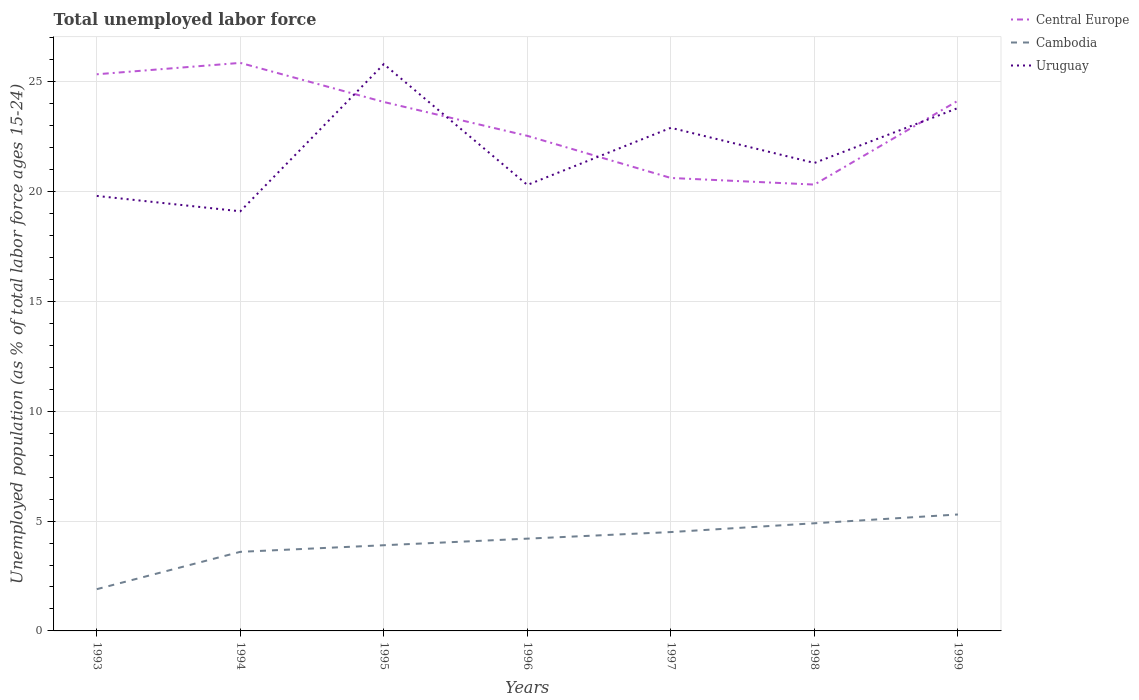Across all years, what is the maximum percentage of unemployed population in in Uruguay?
Offer a very short reply. 19.1. What is the total percentage of unemployed population in in Cambodia in the graph?
Give a very brief answer. -0.3. What is the difference between the highest and the second highest percentage of unemployed population in in Cambodia?
Ensure brevity in your answer.  3.4. What is the difference between the highest and the lowest percentage of unemployed population in in Uruguay?
Ensure brevity in your answer.  3. Is the percentage of unemployed population in in Central Europe strictly greater than the percentage of unemployed population in in Uruguay over the years?
Provide a short and direct response. No. How many lines are there?
Your answer should be very brief. 3. Does the graph contain any zero values?
Keep it short and to the point. No. How many legend labels are there?
Keep it short and to the point. 3. What is the title of the graph?
Provide a short and direct response. Total unemployed labor force. What is the label or title of the Y-axis?
Provide a short and direct response. Unemployed population (as % of total labor force ages 15-24). What is the Unemployed population (as % of total labor force ages 15-24) of Central Europe in 1993?
Offer a terse response. 25.34. What is the Unemployed population (as % of total labor force ages 15-24) in Cambodia in 1993?
Your response must be concise. 1.9. What is the Unemployed population (as % of total labor force ages 15-24) of Uruguay in 1993?
Your answer should be very brief. 19.8. What is the Unemployed population (as % of total labor force ages 15-24) in Central Europe in 1994?
Provide a short and direct response. 25.85. What is the Unemployed population (as % of total labor force ages 15-24) in Cambodia in 1994?
Keep it short and to the point. 3.6. What is the Unemployed population (as % of total labor force ages 15-24) of Uruguay in 1994?
Your answer should be very brief. 19.1. What is the Unemployed population (as % of total labor force ages 15-24) in Central Europe in 1995?
Your response must be concise. 24.07. What is the Unemployed population (as % of total labor force ages 15-24) of Cambodia in 1995?
Keep it short and to the point. 3.9. What is the Unemployed population (as % of total labor force ages 15-24) of Uruguay in 1995?
Your answer should be very brief. 25.8. What is the Unemployed population (as % of total labor force ages 15-24) in Central Europe in 1996?
Provide a succinct answer. 22.53. What is the Unemployed population (as % of total labor force ages 15-24) of Cambodia in 1996?
Provide a short and direct response. 4.2. What is the Unemployed population (as % of total labor force ages 15-24) of Uruguay in 1996?
Provide a short and direct response. 20.3. What is the Unemployed population (as % of total labor force ages 15-24) of Central Europe in 1997?
Provide a succinct answer. 20.62. What is the Unemployed population (as % of total labor force ages 15-24) of Uruguay in 1997?
Give a very brief answer. 22.9. What is the Unemployed population (as % of total labor force ages 15-24) of Central Europe in 1998?
Provide a short and direct response. 20.32. What is the Unemployed population (as % of total labor force ages 15-24) in Cambodia in 1998?
Your answer should be compact. 4.9. What is the Unemployed population (as % of total labor force ages 15-24) of Uruguay in 1998?
Offer a terse response. 21.3. What is the Unemployed population (as % of total labor force ages 15-24) in Central Europe in 1999?
Your response must be concise. 24.13. What is the Unemployed population (as % of total labor force ages 15-24) of Cambodia in 1999?
Ensure brevity in your answer.  5.3. What is the Unemployed population (as % of total labor force ages 15-24) of Uruguay in 1999?
Give a very brief answer. 23.8. Across all years, what is the maximum Unemployed population (as % of total labor force ages 15-24) in Central Europe?
Give a very brief answer. 25.85. Across all years, what is the maximum Unemployed population (as % of total labor force ages 15-24) in Cambodia?
Your answer should be very brief. 5.3. Across all years, what is the maximum Unemployed population (as % of total labor force ages 15-24) in Uruguay?
Your answer should be compact. 25.8. Across all years, what is the minimum Unemployed population (as % of total labor force ages 15-24) of Central Europe?
Your answer should be compact. 20.32. Across all years, what is the minimum Unemployed population (as % of total labor force ages 15-24) of Cambodia?
Your answer should be compact. 1.9. Across all years, what is the minimum Unemployed population (as % of total labor force ages 15-24) of Uruguay?
Offer a very short reply. 19.1. What is the total Unemployed population (as % of total labor force ages 15-24) of Central Europe in the graph?
Your answer should be very brief. 162.86. What is the total Unemployed population (as % of total labor force ages 15-24) in Cambodia in the graph?
Your response must be concise. 28.3. What is the total Unemployed population (as % of total labor force ages 15-24) of Uruguay in the graph?
Provide a short and direct response. 153. What is the difference between the Unemployed population (as % of total labor force ages 15-24) of Central Europe in 1993 and that in 1994?
Your answer should be very brief. -0.52. What is the difference between the Unemployed population (as % of total labor force ages 15-24) of Cambodia in 1993 and that in 1994?
Make the answer very short. -1.7. What is the difference between the Unemployed population (as % of total labor force ages 15-24) of Uruguay in 1993 and that in 1994?
Ensure brevity in your answer.  0.7. What is the difference between the Unemployed population (as % of total labor force ages 15-24) in Central Europe in 1993 and that in 1995?
Keep it short and to the point. 1.26. What is the difference between the Unemployed population (as % of total labor force ages 15-24) in Uruguay in 1993 and that in 1995?
Ensure brevity in your answer.  -6. What is the difference between the Unemployed population (as % of total labor force ages 15-24) of Central Europe in 1993 and that in 1996?
Your response must be concise. 2.8. What is the difference between the Unemployed population (as % of total labor force ages 15-24) of Uruguay in 1993 and that in 1996?
Make the answer very short. -0.5. What is the difference between the Unemployed population (as % of total labor force ages 15-24) in Central Europe in 1993 and that in 1997?
Provide a short and direct response. 4.72. What is the difference between the Unemployed population (as % of total labor force ages 15-24) in Cambodia in 1993 and that in 1997?
Your answer should be compact. -2.6. What is the difference between the Unemployed population (as % of total labor force ages 15-24) of Central Europe in 1993 and that in 1998?
Give a very brief answer. 5.02. What is the difference between the Unemployed population (as % of total labor force ages 15-24) in Cambodia in 1993 and that in 1998?
Give a very brief answer. -3. What is the difference between the Unemployed population (as % of total labor force ages 15-24) in Central Europe in 1993 and that in 1999?
Offer a very short reply. 1.2. What is the difference between the Unemployed population (as % of total labor force ages 15-24) of Cambodia in 1993 and that in 1999?
Give a very brief answer. -3.4. What is the difference between the Unemployed population (as % of total labor force ages 15-24) of Central Europe in 1994 and that in 1995?
Your response must be concise. 1.78. What is the difference between the Unemployed population (as % of total labor force ages 15-24) in Cambodia in 1994 and that in 1995?
Your answer should be compact. -0.3. What is the difference between the Unemployed population (as % of total labor force ages 15-24) in Central Europe in 1994 and that in 1996?
Provide a succinct answer. 3.32. What is the difference between the Unemployed population (as % of total labor force ages 15-24) of Cambodia in 1994 and that in 1996?
Your answer should be very brief. -0.6. What is the difference between the Unemployed population (as % of total labor force ages 15-24) in Central Europe in 1994 and that in 1997?
Offer a terse response. 5.24. What is the difference between the Unemployed population (as % of total labor force ages 15-24) of Cambodia in 1994 and that in 1997?
Provide a succinct answer. -0.9. What is the difference between the Unemployed population (as % of total labor force ages 15-24) in Central Europe in 1994 and that in 1998?
Give a very brief answer. 5.54. What is the difference between the Unemployed population (as % of total labor force ages 15-24) of Cambodia in 1994 and that in 1998?
Keep it short and to the point. -1.3. What is the difference between the Unemployed population (as % of total labor force ages 15-24) in Uruguay in 1994 and that in 1998?
Give a very brief answer. -2.2. What is the difference between the Unemployed population (as % of total labor force ages 15-24) in Central Europe in 1994 and that in 1999?
Provide a short and direct response. 1.72. What is the difference between the Unemployed population (as % of total labor force ages 15-24) in Uruguay in 1994 and that in 1999?
Provide a succinct answer. -4.7. What is the difference between the Unemployed population (as % of total labor force ages 15-24) in Central Europe in 1995 and that in 1996?
Ensure brevity in your answer.  1.54. What is the difference between the Unemployed population (as % of total labor force ages 15-24) in Cambodia in 1995 and that in 1996?
Provide a succinct answer. -0.3. What is the difference between the Unemployed population (as % of total labor force ages 15-24) of Central Europe in 1995 and that in 1997?
Provide a short and direct response. 3.46. What is the difference between the Unemployed population (as % of total labor force ages 15-24) in Cambodia in 1995 and that in 1997?
Provide a succinct answer. -0.6. What is the difference between the Unemployed population (as % of total labor force ages 15-24) of Uruguay in 1995 and that in 1997?
Your answer should be very brief. 2.9. What is the difference between the Unemployed population (as % of total labor force ages 15-24) of Central Europe in 1995 and that in 1998?
Make the answer very short. 3.76. What is the difference between the Unemployed population (as % of total labor force ages 15-24) of Uruguay in 1995 and that in 1998?
Ensure brevity in your answer.  4.5. What is the difference between the Unemployed population (as % of total labor force ages 15-24) of Central Europe in 1995 and that in 1999?
Your response must be concise. -0.06. What is the difference between the Unemployed population (as % of total labor force ages 15-24) in Cambodia in 1995 and that in 1999?
Keep it short and to the point. -1.4. What is the difference between the Unemployed population (as % of total labor force ages 15-24) of Uruguay in 1995 and that in 1999?
Your answer should be very brief. 2. What is the difference between the Unemployed population (as % of total labor force ages 15-24) in Central Europe in 1996 and that in 1997?
Offer a very short reply. 1.92. What is the difference between the Unemployed population (as % of total labor force ages 15-24) in Central Europe in 1996 and that in 1998?
Make the answer very short. 2.22. What is the difference between the Unemployed population (as % of total labor force ages 15-24) of Uruguay in 1996 and that in 1998?
Ensure brevity in your answer.  -1. What is the difference between the Unemployed population (as % of total labor force ages 15-24) in Central Europe in 1996 and that in 1999?
Ensure brevity in your answer.  -1.6. What is the difference between the Unemployed population (as % of total labor force ages 15-24) of Central Europe in 1997 and that in 1998?
Ensure brevity in your answer.  0.3. What is the difference between the Unemployed population (as % of total labor force ages 15-24) of Uruguay in 1997 and that in 1998?
Your response must be concise. 1.6. What is the difference between the Unemployed population (as % of total labor force ages 15-24) in Central Europe in 1997 and that in 1999?
Offer a very short reply. -3.52. What is the difference between the Unemployed population (as % of total labor force ages 15-24) of Cambodia in 1997 and that in 1999?
Your answer should be compact. -0.8. What is the difference between the Unemployed population (as % of total labor force ages 15-24) of Central Europe in 1998 and that in 1999?
Your answer should be compact. -3.82. What is the difference between the Unemployed population (as % of total labor force ages 15-24) of Cambodia in 1998 and that in 1999?
Offer a terse response. -0.4. What is the difference between the Unemployed population (as % of total labor force ages 15-24) of Uruguay in 1998 and that in 1999?
Ensure brevity in your answer.  -2.5. What is the difference between the Unemployed population (as % of total labor force ages 15-24) in Central Europe in 1993 and the Unemployed population (as % of total labor force ages 15-24) in Cambodia in 1994?
Your response must be concise. 21.74. What is the difference between the Unemployed population (as % of total labor force ages 15-24) in Central Europe in 1993 and the Unemployed population (as % of total labor force ages 15-24) in Uruguay in 1994?
Your answer should be compact. 6.24. What is the difference between the Unemployed population (as % of total labor force ages 15-24) in Cambodia in 1993 and the Unemployed population (as % of total labor force ages 15-24) in Uruguay in 1994?
Give a very brief answer. -17.2. What is the difference between the Unemployed population (as % of total labor force ages 15-24) in Central Europe in 1993 and the Unemployed population (as % of total labor force ages 15-24) in Cambodia in 1995?
Your answer should be very brief. 21.44. What is the difference between the Unemployed population (as % of total labor force ages 15-24) in Central Europe in 1993 and the Unemployed population (as % of total labor force ages 15-24) in Uruguay in 1995?
Give a very brief answer. -0.46. What is the difference between the Unemployed population (as % of total labor force ages 15-24) of Cambodia in 1993 and the Unemployed population (as % of total labor force ages 15-24) of Uruguay in 1995?
Your response must be concise. -23.9. What is the difference between the Unemployed population (as % of total labor force ages 15-24) of Central Europe in 1993 and the Unemployed population (as % of total labor force ages 15-24) of Cambodia in 1996?
Make the answer very short. 21.14. What is the difference between the Unemployed population (as % of total labor force ages 15-24) in Central Europe in 1993 and the Unemployed population (as % of total labor force ages 15-24) in Uruguay in 1996?
Your response must be concise. 5.04. What is the difference between the Unemployed population (as % of total labor force ages 15-24) in Cambodia in 1993 and the Unemployed population (as % of total labor force ages 15-24) in Uruguay in 1996?
Offer a terse response. -18.4. What is the difference between the Unemployed population (as % of total labor force ages 15-24) of Central Europe in 1993 and the Unemployed population (as % of total labor force ages 15-24) of Cambodia in 1997?
Give a very brief answer. 20.84. What is the difference between the Unemployed population (as % of total labor force ages 15-24) in Central Europe in 1993 and the Unemployed population (as % of total labor force ages 15-24) in Uruguay in 1997?
Offer a terse response. 2.44. What is the difference between the Unemployed population (as % of total labor force ages 15-24) of Central Europe in 1993 and the Unemployed population (as % of total labor force ages 15-24) of Cambodia in 1998?
Your answer should be compact. 20.44. What is the difference between the Unemployed population (as % of total labor force ages 15-24) in Central Europe in 1993 and the Unemployed population (as % of total labor force ages 15-24) in Uruguay in 1998?
Your answer should be very brief. 4.04. What is the difference between the Unemployed population (as % of total labor force ages 15-24) of Cambodia in 1993 and the Unemployed population (as % of total labor force ages 15-24) of Uruguay in 1998?
Your answer should be compact. -19.4. What is the difference between the Unemployed population (as % of total labor force ages 15-24) in Central Europe in 1993 and the Unemployed population (as % of total labor force ages 15-24) in Cambodia in 1999?
Your answer should be compact. 20.04. What is the difference between the Unemployed population (as % of total labor force ages 15-24) in Central Europe in 1993 and the Unemployed population (as % of total labor force ages 15-24) in Uruguay in 1999?
Your answer should be compact. 1.54. What is the difference between the Unemployed population (as % of total labor force ages 15-24) of Cambodia in 1993 and the Unemployed population (as % of total labor force ages 15-24) of Uruguay in 1999?
Your answer should be very brief. -21.9. What is the difference between the Unemployed population (as % of total labor force ages 15-24) of Central Europe in 1994 and the Unemployed population (as % of total labor force ages 15-24) of Cambodia in 1995?
Your answer should be very brief. 21.95. What is the difference between the Unemployed population (as % of total labor force ages 15-24) in Central Europe in 1994 and the Unemployed population (as % of total labor force ages 15-24) in Uruguay in 1995?
Your answer should be very brief. 0.05. What is the difference between the Unemployed population (as % of total labor force ages 15-24) in Cambodia in 1994 and the Unemployed population (as % of total labor force ages 15-24) in Uruguay in 1995?
Give a very brief answer. -22.2. What is the difference between the Unemployed population (as % of total labor force ages 15-24) in Central Europe in 1994 and the Unemployed population (as % of total labor force ages 15-24) in Cambodia in 1996?
Offer a terse response. 21.65. What is the difference between the Unemployed population (as % of total labor force ages 15-24) of Central Europe in 1994 and the Unemployed population (as % of total labor force ages 15-24) of Uruguay in 1996?
Keep it short and to the point. 5.55. What is the difference between the Unemployed population (as % of total labor force ages 15-24) in Cambodia in 1994 and the Unemployed population (as % of total labor force ages 15-24) in Uruguay in 1996?
Provide a short and direct response. -16.7. What is the difference between the Unemployed population (as % of total labor force ages 15-24) in Central Europe in 1994 and the Unemployed population (as % of total labor force ages 15-24) in Cambodia in 1997?
Your response must be concise. 21.35. What is the difference between the Unemployed population (as % of total labor force ages 15-24) of Central Europe in 1994 and the Unemployed population (as % of total labor force ages 15-24) of Uruguay in 1997?
Offer a very short reply. 2.95. What is the difference between the Unemployed population (as % of total labor force ages 15-24) in Cambodia in 1994 and the Unemployed population (as % of total labor force ages 15-24) in Uruguay in 1997?
Make the answer very short. -19.3. What is the difference between the Unemployed population (as % of total labor force ages 15-24) in Central Europe in 1994 and the Unemployed population (as % of total labor force ages 15-24) in Cambodia in 1998?
Make the answer very short. 20.95. What is the difference between the Unemployed population (as % of total labor force ages 15-24) in Central Europe in 1994 and the Unemployed population (as % of total labor force ages 15-24) in Uruguay in 1998?
Your answer should be compact. 4.55. What is the difference between the Unemployed population (as % of total labor force ages 15-24) of Cambodia in 1994 and the Unemployed population (as % of total labor force ages 15-24) of Uruguay in 1998?
Make the answer very short. -17.7. What is the difference between the Unemployed population (as % of total labor force ages 15-24) in Central Europe in 1994 and the Unemployed population (as % of total labor force ages 15-24) in Cambodia in 1999?
Keep it short and to the point. 20.55. What is the difference between the Unemployed population (as % of total labor force ages 15-24) in Central Europe in 1994 and the Unemployed population (as % of total labor force ages 15-24) in Uruguay in 1999?
Your response must be concise. 2.05. What is the difference between the Unemployed population (as % of total labor force ages 15-24) in Cambodia in 1994 and the Unemployed population (as % of total labor force ages 15-24) in Uruguay in 1999?
Give a very brief answer. -20.2. What is the difference between the Unemployed population (as % of total labor force ages 15-24) of Central Europe in 1995 and the Unemployed population (as % of total labor force ages 15-24) of Cambodia in 1996?
Offer a very short reply. 19.87. What is the difference between the Unemployed population (as % of total labor force ages 15-24) of Central Europe in 1995 and the Unemployed population (as % of total labor force ages 15-24) of Uruguay in 1996?
Give a very brief answer. 3.77. What is the difference between the Unemployed population (as % of total labor force ages 15-24) of Cambodia in 1995 and the Unemployed population (as % of total labor force ages 15-24) of Uruguay in 1996?
Provide a succinct answer. -16.4. What is the difference between the Unemployed population (as % of total labor force ages 15-24) of Central Europe in 1995 and the Unemployed population (as % of total labor force ages 15-24) of Cambodia in 1997?
Offer a terse response. 19.57. What is the difference between the Unemployed population (as % of total labor force ages 15-24) in Central Europe in 1995 and the Unemployed population (as % of total labor force ages 15-24) in Uruguay in 1997?
Ensure brevity in your answer.  1.17. What is the difference between the Unemployed population (as % of total labor force ages 15-24) in Central Europe in 1995 and the Unemployed population (as % of total labor force ages 15-24) in Cambodia in 1998?
Give a very brief answer. 19.17. What is the difference between the Unemployed population (as % of total labor force ages 15-24) in Central Europe in 1995 and the Unemployed population (as % of total labor force ages 15-24) in Uruguay in 1998?
Offer a very short reply. 2.77. What is the difference between the Unemployed population (as % of total labor force ages 15-24) in Cambodia in 1995 and the Unemployed population (as % of total labor force ages 15-24) in Uruguay in 1998?
Your answer should be compact. -17.4. What is the difference between the Unemployed population (as % of total labor force ages 15-24) in Central Europe in 1995 and the Unemployed population (as % of total labor force ages 15-24) in Cambodia in 1999?
Provide a short and direct response. 18.77. What is the difference between the Unemployed population (as % of total labor force ages 15-24) in Central Europe in 1995 and the Unemployed population (as % of total labor force ages 15-24) in Uruguay in 1999?
Offer a terse response. 0.27. What is the difference between the Unemployed population (as % of total labor force ages 15-24) of Cambodia in 1995 and the Unemployed population (as % of total labor force ages 15-24) of Uruguay in 1999?
Ensure brevity in your answer.  -19.9. What is the difference between the Unemployed population (as % of total labor force ages 15-24) of Central Europe in 1996 and the Unemployed population (as % of total labor force ages 15-24) of Cambodia in 1997?
Offer a terse response. 18.03. What is the difference between the Unemployed population (as % of total labor force ages 15-24) in Central Europe in 1996 and the Unemployed population (as % of total labor force ages 15-24) in Uruguay in 1997?
Keep it short and to the point. -0.37. What is the difference between the Unemployed population (as % of total labor force ages 15-24) of Cambodia in 1996 and the Unemployed population (as % of total labor force ages 15-24) of Uruguay in 1997?
Offer a very short reply. -18.7. What is the difference between the Unemployed population (as % of total labor force ages 15-24) in Central Europe in 1996 and the Unemployed population (as % of total labor force ages 15-24) in Cambodia in 1998?
Make the answer very short. 17.63. What is the difference between the Unemployed population (as % of total labor force ages 15-24) of Central Europe in 1996 and the Unemployed population (as % of total labor force ages 15-24) of Uruguay in 1998?
Keep it short and to the point. 1.23. What is the difference between the Unemployed population (as % of total labor force ages 15-24) in Cambodia in 1996 and the Unemployed population (as % of total labor force ages 15-24) in Uruguay in 1998?
Your answer should be very brief. -17.1. What is the difference between the Unemployed population (as % of total labor force ages 15-24) in Central Europe in 1996 and the Unemployed population (as % of total labor force ages 15-24) in Cambodia in 1999?
Your response must be concise. 17.23. What is the difference between the Unemployed population (as % of total labor force ages 15-24) of Central Europe in 1996 and the Unemployed population (as % of total labor force ages 15-24) of Uruguay in 1999?
Keep it short and to the point. -1.27. What is the difference between the Unemployed population (as % of total labor force ages 15-24) of Cambodia in 1996 and the Unemployed population (as % of total labor force ages 15-24) of Uruguay in 1999?
Your answer should be very brief. -19.6. What is the difference between the Unemployed population (as % of total labor force ages 15-24) in Central Europe in 1997 and the Unemployed population (as % of total labor force ages 15-24) in Cambodia in 1998?
Offer a terse response. 15.72. What is the difference between the Unemployed population (as % of total labor force ages 15-24) of Central Europe in 1997 and the Unemployed population (as % of total labor force ages 15-24) of Uruguay in 1998?
Offer a very short reply. -0.68. What is the difference between the Unemployed population (as % of total labor force ages 15-24) of Cambodia in 1997 and the Unemployed population (as % of total labor force ages 15-24) of Uruguay in 1998?
Provide a short and direct response. -16.8. What is the difference between the Unemployed population (as % of total labor force ages 15-24) of Central Europe in 1997 and the Unemployed population (as % of total labor force ages 15-24) of Cambodia in 1999?
Offer a very short reply. 15.32. What is the difference between the Unemployed population (as % of total labor force ages 15-24) in Central Europe in 1997 and the Unemployed population (as % of total labor force ages 15-24) in Uruguay in 1999?
Give a very brief answer. -3.18. What is the difference between the Unemployed population (as % of total labor force ages 15-24) of Cambodia in 1997 and the Unemployed population (as % of total labor force ages 15-24) of Uruguay in 1999?
Your response must be concise. -19.3. What is the difference between the Unemployed population (as % of total labor force ages 15-24) in Central Europe in 1998 and the Unemployed population (as % of total labor force ages 15-24) in Cambodia in 1999?
Offer a very short reply. 15.02. What is the difference between the Unemployed population (as % of total labor force ages 15-24) in Central Europe in 1998 and the Unemployed population (as % of total labor force ages 15-24) in Uruguay in 1999?
Keep it short and to the point. -3.48. What is the difference between the Unemployed population (as % of total labor force ages 15-24) of Cambodia in 1998 and the Unemployed population (as % of total labor force ages 15-24) of Uruguay in 1999?
Ensure brevity in your answer.  -18.9. What is the average Unemployed population (as % of total labor force ages 15-24) of Central Europe per year?
Give a very brief answer. 23.27. What is the average Unemployed population (as % of total labor force ages 15-24) of Cambodia per year?
Give a very brief answer. 4.04. What is the average Unemployed population (as % of total labor force ages 15-24) in Uruguay per year?
Make the answer very short. 21.86. In the year 1993, what is the difference between the Unemployed population (as % of total labor force ages 15-24) of Central Europe and Unemployed population (as % of total labor force ages 15-24) of Cambodia?
Provide a short and direct response. 23.44. In the year 1993, what is the difference between the Unemployed population (as % of total labor force ages 15-24) in Central Europe and Unemployed population (as % of total labor force ages 15-24) in Uruguay?
Give a very brief answer. 5.54. In the year 1993, what is the difference between the Unemployed population (as % of total labor force ages 15-24) in Cambodia and Unemployed population (as % of total labor force ages 15-24) in Uruguay?
Keep it short and to the point. -17.9. In the year 1994, what is the difference between the Unemployed population (as % of total labor force ages 15-24) of Central Europe and Unemployed population (as % of total labor force ages 15-24) of Cambodia?
Your answer should be very brief. 22.25. In the year 1994, what is the difference between the Unemployed population (as % of total labor force ages 15-24) in Central Europe and Unemployed population (as % of total labor force ages 15-24) in Uruguay?
Provide a succinct answer. 6.75. In the year 1994, what is the difference between the Unemployed population (as % of total labor force ages 15-24) in Cambodia and Unemployed population (as % of total labor force ages 15-24) in Uruguay?
Ensure brevity in your answer.  -15.5. In the year 1995, what is the difference between the Unemployed population (as % of total labor force ages 15-24) in Central Europe and Unemployed population (as % of total labor force ages 15-24) in Cambodia?
Make the answer very short. 20.17. In the year 1995, what is the difference between the Unemployed population (as % of total labor force ages 15-24) of Central Europe and Unemployed population (as % of total labor force ages 15-24) of Uruguay?
Keep it short and to the point. -1.73. In the year 1995, what is the difference between the Unemployed population (as % of total labor force ages 15-24) of Cambodia and Unemployed population (as % of total labor force ages 15-24) of Uruguay?
Your response must be concise. -21.9. In the year 1996, what is the difference between the Unemployed population (as % of total labor force ages 15-24) in Central Europe and Unemployed population (as % of total labor force ages 15-24) in Cambodia?
Your answer should be very brief. 18.33. In the year 1996, what is the difference between the Unemployed population (as % of total labor force ages 15-24) of Central Europe and Unemployed population (as % of total labor force ages 15-24) of Uruguay?
Your answer should be compact. 2.23. In the year 1996, what is the difference between the Unemployed population (as % of total labor force ages 15-24) in Cambodia and Unemployed population (as % of total labor force ages 15-24) in Uruguay?
Offer a terse response. -16.1. In the year 1997, what is the difference between the Unemployed population (as % of total labor force ages 15-24) of Central Europe and Unemployed population (as % of total labor force ages 15-24) of Cambodia?
Ensure brevity in your answer.  16.12. In the year 1997, what is the difference between the Unemployed population (as % of total labor force ages 15-24) of Central Europe and Unemployed population (as % of total labor force ages 15-24) of Uruguay?
Offer a terse response. -2.28. In the year 1997, what is the difference between the Unemployed population (as % of total labor force ages 15-24) in Cambodia and Unemployed population (as % of total labor force ages 15-24) in Uruguay?
Keep it short and to the point. -18.4. In the year 1998, what is the difference between the Unemployed population (as % of total labor force ages 15-24) in Central Europe and Unemployed population (as % of total labor force ages 15-24) in Cambodia?
Keep it short and to the point. 15.42. In the year 1998, what is the difference between the Unemployed population (as % of total labor force ages 15-24) in Central Europe and Unemployed population (as % of total labor force ages 15-24) in Uruguay?
Provide a succinct answer. -0.98. In the year 1998, what is the difference between the Unemployed population (as % of total labor force ages 15-24) of Cambodia and Unemployed population (as % of total labor force ages 15-24) of Uruguay?
Provide a short and direct response. -16.4. In the year 1999, what is the difference between the Unemployed population (as % of total labor force ages 15-24) in Central Europe and Unemployed population (as % of total labor force ages 15-24) in Cambodia?
Offer a very short reply. 18.83. In the year 1999, what is the difference between the Unemployed population (as % of total labor force ages 15-24) of Central Europe and Unemployed population (as % of total labor force ages 15-24) of Uruguay?
Provide a succinct answer. 0.33. In the year 1999, what is the difference between the Unemployed population (as % of total labor force ages 15-24) in Cambodia and Unemployed population (as % of total labor force ages 15-24) in Uruguay?
Your answer should be compact. -18.5. What is the ratio of the Unemployed population (as % of total labor force ages 15-24) of Cambodia in 1993 to that in 1994?
Make the answer very short. 0.53. What is the ratio of the Unemployed population (as % of total labor force ages 15-24) in Uruguay in 1993 to that in 1994?
Your answer should be compact. 1.04. What is the ratio of the Unemployed population (as % of total labor force ages 15-24) of Central Europe in 1993 to that in 1995?
Keep it short and to the point. 1.05. What is the ratio of the Unemployed population (as % of total labor force ages 15-24) in Cambodia in 1993 to that in 1995?
Give a very brief answer. 0.49. What is the ratio of the Unemployed population (as % of total labor force ages 15-24) of Uruguay in 1993 to that in 1995?
Make the answer very short. 0.77. What is the ratio of the Unemployed population (as % of total labor force ages 15-24) of Central Europe in 1993 to that in 1996?
Provide a short and direct response. 1.12. What is the ratio of the Unemployed population (as % of total labor force ages 15-24) of Cambodia in 1993 to that in 1996?
Make the answer very short. 0.45. What is the ratio of the Unemployed population (as % of total labor force ages 15-24) of Uruguay in 1993 to that in 1996?
Provide a succinct answer. 0.98. What is the ratio of the Unemployed population (as % of total labor force ages 15-24) in Central Europe in 1993 to that in 1997?
Provide a short and direct response. 1.23. What is the ratio of the Unemployed population (as % of total labor force ages 15-24) of Cambodia in 1993 to that in 1997?
Give a very brief answer. 0.42. What is the ratio of the Unemployed population (as % of total labor force ages 15-24) of Uruguay in 1993 to that in 1997?
Give a very brief answer. 0.86. What is the ratio of the Unemployed population (as % of total labor force ages 15-24) of Central Europe in 1993 to that in 1998?
Ensure brevity in your answer.  1.25. What is the ratio of the Unemployed population (as % of total labor force ages 15-24) of Cambodia in 1993 to that in 1998?
Offer a very short reply. 0.39. What is the ratio of the Unemployed population (as % of total labor force ages 15-24) of Uruguay in 1993 to that in 1998?
Make the answer very short. 0.93. What is the ratio of the Unemployed population (as % of total labor force ages 15-24) in Central Europe in 1993 to that in 1999?
Your answer should be very brief. 1.05. What is the ratio of the Unemployed population (as % of total labor force ages 15-24) in Cambodia in 1993 to that in 1999?
Offer a terse response. 0.36. What is the ratio of the Unemployed population (as % of total labor force ages 15-24) in Uruguay in 1993 to that in 1999?
Provide a succinct answer. 0.83. What is the ratio of the Unemployed population (as % of total labor force ages 15-24) of Central Europe in 1994 to that in 1995?
Your answer should be very brief. 1.07. What is the ratio of the Unemployed population (as % of total labor force ages 15-24) of Uruguay in 1994 to that in 1995?
Your answer should be compact. 0.74. What is the ratio of the Unemployed population (as % of total labor force ages 15-24) in Central Europe in 1994 to that in 1996?
Your answer should be very brief. 1.15. What is the ratio of the Unemployed population (as % of total labor force ages 15-24) in Uruguay in 1994 to that in 1996?
Make the answer very short. 0.94. What is the ratio of the Unemployed population (as % of total labor force ages 15-24) of Central Europe in 1994 to that in 1997?
Offer a terse response. 1.25. What is the ratio of the Unemployed population (as % of total labor force ages 15-24) in Cambodia in 1994 to that in 1997?
Offer a very short reply. 0.8. What is the ratio of the Unemployed population (as % of total labor force ages 15-24) in Uruguay in 1994 to that in 1997?
Your response must be concise. 0.83. What is the ratio of the Unemployed population (as % of total labor force ages 15-24) in Central Europe in 1994 to that in 1998?
Your response must be concise. 1.27. What is the ratio of the Unemployed population (as % of total labor force ages 15-24) of Cambodia in 1994 to that in 1998?
Provide a succinct answer. 0.73. What is the ratio of the Unemployed population (as % of total labor force ages 15-24) in Uruguay in 1994 to that in 1998?
Give a very brief answer. 0.9. What is the ratio of the Unemployed population (as % of total labor force ages 15-24) of Central Europe in 1994 to that in 1999?
Ensure brevity in your answer.  1.07. What is the ratio of the Unemployed population (as % of total labor force ages 15-24) in Cambodia in 1994 to that in 1999?
Your answer should be compact. 0.68. What is the ratio of the Unemployed population (as % of total labor force ages 15-24) of Uruguay in 1994 to that in 1999?
Provide a succinct answer. 0.8. What is the ratio of the Unemployed population (as % of total labor force ages 15-24) of Central Europe in 1995 to that in 1996?
Keep it short and to the point. 1.07. What is the ratio of the Unemployed population (as % of total labor force ages 15-24) of Uruguay in 1995 to that in 1996?
Give a very brief answer. 1.27. What is the ratio of the Unemployed population (as % of total labor force ages 15-24) of Central Europe in 1995 to that in 1997?
Ensure brevity in your answer.  1.17. What is the ratio of the Unemployed population (as % of total labor force ages 15-24) in Cambodia in 1995 to that in 1997?
Your answer should be compact. 0.87. What is the ratio of the Unemployed population (as % of total labor force ages 15-24) of Uruguay in 1995 to that in 1997?
Make the answer very short. 1.13. What is the ratio of the Unemployed population (as % of total labor force ages 15-24) of Central Europe in 1995 to that in 1998?
Keep it short and to the point. 1.19. What is the ratio of the Unemployed population (as % of total labor force ages 15-24) in Cambodia in 1995 to that in 1998?
Your answer should be very brief. 0.8. What is the ratio of the Unemployed population (as % of total labor force ages 15-24) of Uruguay in 1995 to that in 1998?
Make the answer very short. 1.21. What is the ratio of the Unemployed population (as % of total labor force ages 15-24) in Cambodia in 1995 to that in 1999?
Give a very brief answer. 0.74. What is the ratio of the Unemployed population (as % of total labor force ages 15-24) in Uruguay in 1995 to that in 1999?
Give a very brief answer. 1.08. What is the ratio of the Unemployed population (as % of total labor force ages 15-24) of Central Europe in 1996 to that in 1997?
Your answer should be compact. 1.09. What is the ratio of the Unemployed population (as % of total labor force ages 15-24) of Uruguay in 1996 to that in 1997?
Your answer should be very brief. 0.89. What is the ratio of the Unemployed population (as % of total labor force ages 15-24) of Central Europe in 1996 to that in 1998?
Your answer should be compact. 1.11. What is the ratio of the Unemployed population (as % of total labor force ages 15-24) of Uruguay in 1996 to that in 1998?
Provide a succinct answer. 0.95. What is the ratio of the Unemployed population (as % of total labor force ages 15-24) in Central Europe in 1996 to that in 1999?
Your answer should be very brief. 0.93. What is the ratio of the Unemployed population (as % of total labor force ages 15-24) of Cambodia in 1996 to that in 1999?
Make the answer very short. 0.79. What is the ratio of the Unemployed population (as % of total labor force ages 15-24) in Uruguay in 1996 to that in 1999?
Give a very brief answer. 0.85. What is the ratio of the Unemployed population (as % of total labor force ages 15-24) in Central Europe in 1997 to that in 1998?
Make the answer very short. 1.01. What is the ratio of the Unemployed population (as % of total labor force ages 15-24) in Cambodia in 1997 to that in 1998?
Keep it short and to the point. 0.92. What is the ratio of the Unemployed population (as % of total labor force ages 15-24) of Uruguay in 1997 to that in 1998?
Your answer should be compact. 1.08. What is the ratio of the Unemployed population (as % of total labor force ages 15-24) of Central Europe in 1997 to that in 1999?
Your answer should be very brief. 0.85. What is the ratio of the Unemployed population (as % of total labor force ages 15-24) in Cambodia in 1997 to that in 1999?
Provide a succinct answer. 0.85. What is the ratio of the Unemployed population (as % of total labor force ages 15-24) of Uruguay in 1997 to that in 1999?
Offer a very short reply. 0.96. What is the ratio of the Unemployed population (as % of total labor force ages 15-24) of Central Europe in 1998 to that in 1999?
Offer a terse response. 0.84. What is the ratio of the Unemployed population (as % of total labor force ages 15-24) in Cambodia in 1998 to that in 1999?
Your answer should be compact. 0.92. What is the ratio of the Unemployed population (as % of total labor force ages 15-24) in Uruguay in 1998 to that in 1999?
Your answer should be very brief. 0.9. What is the difference between the highest and the second highest Unemployed population (as % of total labor force ages 15-24) of Central Europe?
Offer a very short reply. 0.52. What is the difference between the highest and the lowest Unemployed population (as % of total labor force ages 15-24) of Central Europe?
Provide a succinct answer. 5.54. What is the difference between the highest and the lowest Unemployed population (as % of total labor force ages 15-24) of Cambodia?
Provide a succinct answer. 3.4. 